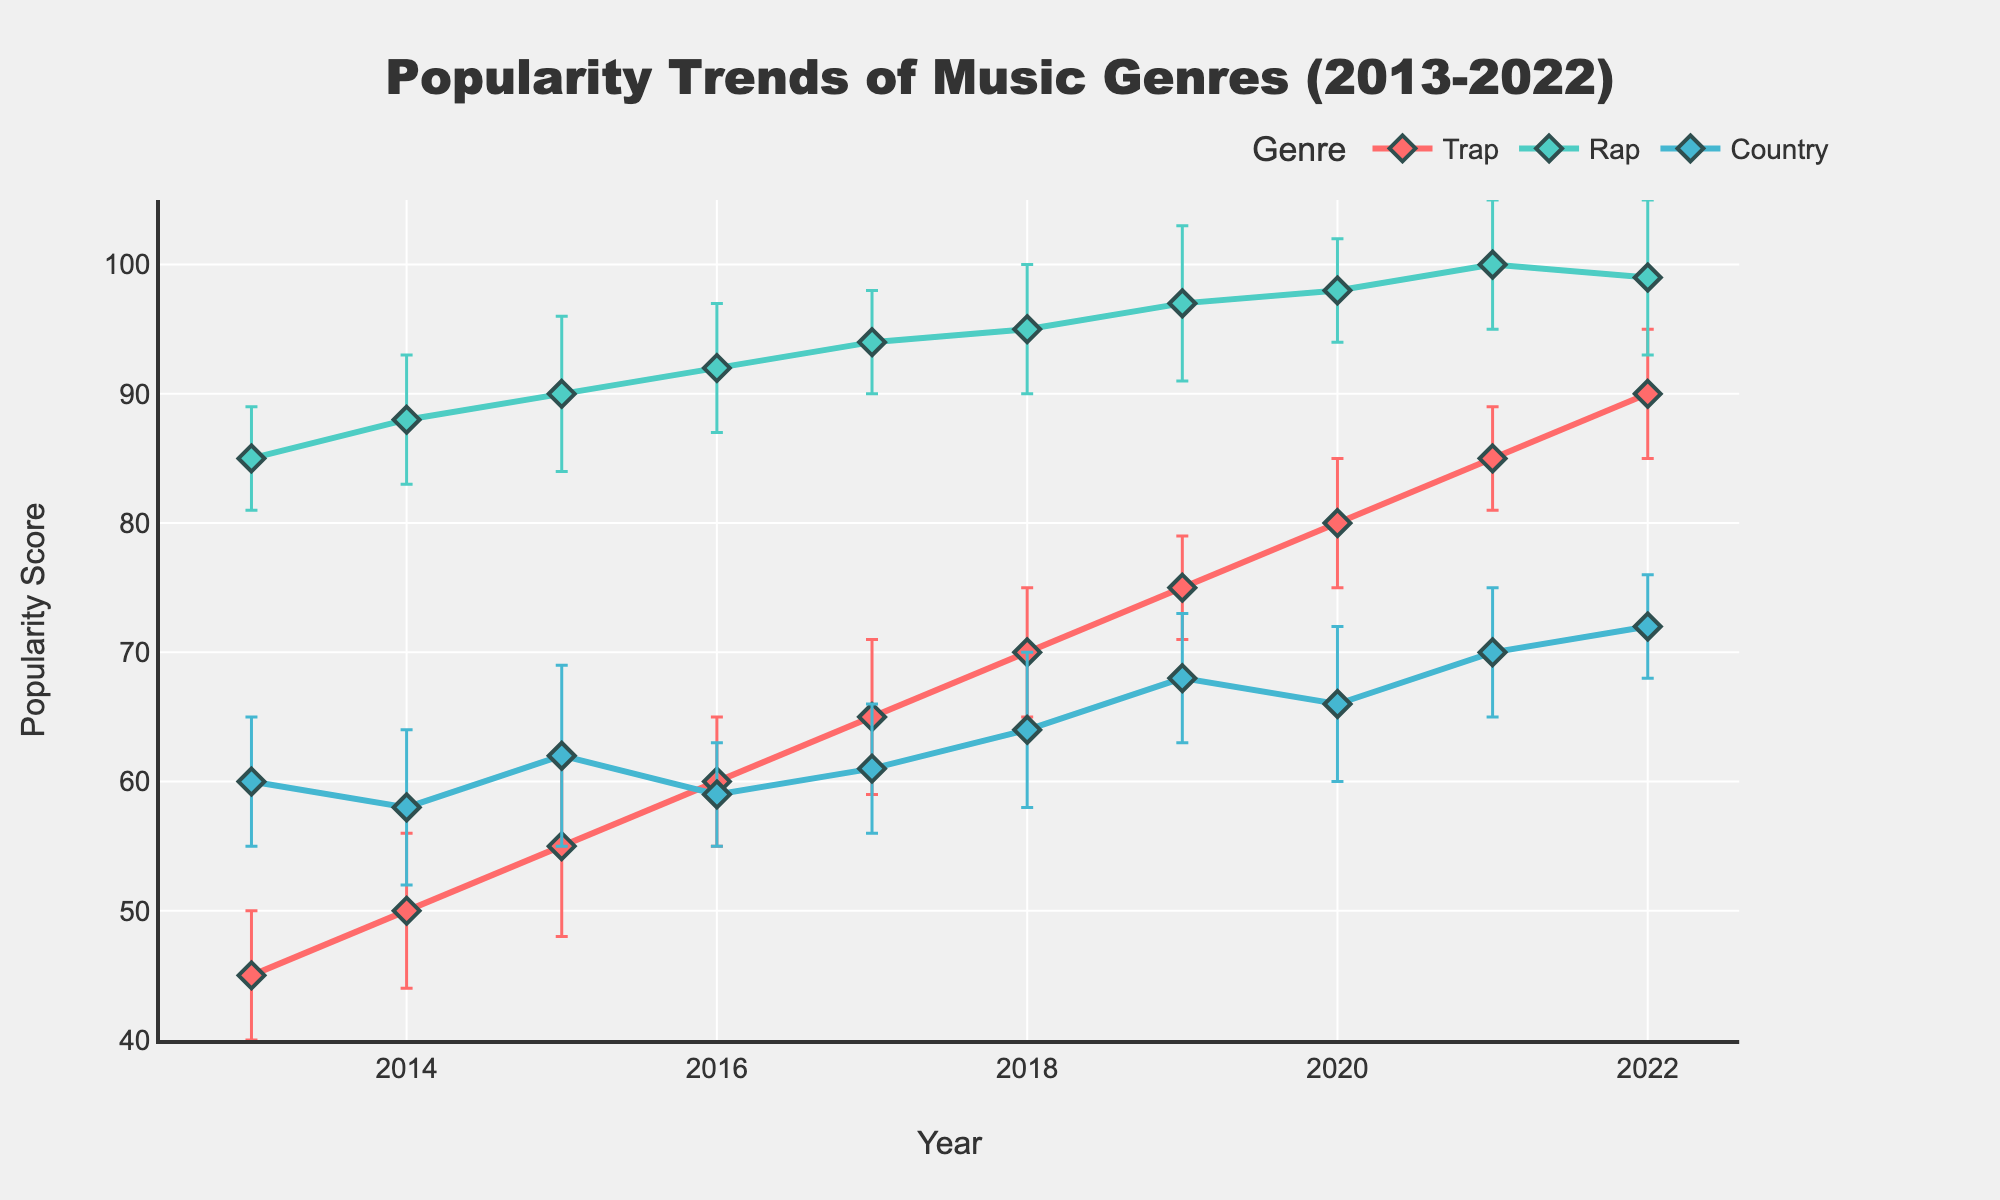What is the title of the plot? The title is displayed at the top of the figure.
Answer: Popularity Trends of Music Genres (2013-2022) What is the popularity of Rap music in 2016? To find the popularity of Rap music in 2016, locate the point corresponding to the year 2016 and the line color representing Rap (teal). The point's vertical position shows a popularity score of 92.
Answer: 92 Which genre had the highest popularity score in 2013? Look at the points for 2013 and identify the one with the highest vertical position. Rap (teal) has the highest score at 85.
Answer: Rap How did the popularity of Trap music change from 2013 to 2022? Determine the popularity score of Trap in 2013 and 2022 by checking the red line's points for these years. From 45 in 2013 to 90 in 2022, the genre's popularity steadily increased.
Answer: Increased What's the difference in popularity between Rap and Country music in 2019? Check the points for 2019 for both genres on their respective lines. Popularity of Rap is 97, and Country is 68. The difference is 97 - 68.
Answer: 29 Which year saw the biggest increase in Trap music's popularity? Compare year-over-year changes for Trap's popularity points and find the largest increase. The biggest jump is from 70 in 2018 to 75 in 2019, an increase of 5.
Answer: 2019 During the period 2013-2022, which genre had the most consistent popularity scores based on error bars? Evaluate the error bars' lengths, representing uncertainty, for each genre. Rap's error bars are relatively short throughout the period compared to Trap and Country, indicating consistency.
Answer: Rap What was the trend of Country music's popularity from 2014 to 2016? Review the points from 2014 to 2016 for Country. Popularity dipped from 58 (2014) to 59 (2016) with ups and downs in between.
Answer: Fluctuated In 2021, how much more popular was Rap compared to Trap? Find the popularity scores for both genres in 2021: Rap is 100, Trap is 85. The difference is 100 - 85.
Answer: 15 Which genre had the highest peak popularity score in the given period? Analyze the highest point reached by each genre's line. Rap hits 100 in 2021, which is the highest score among all genres.
Answer: Rap 